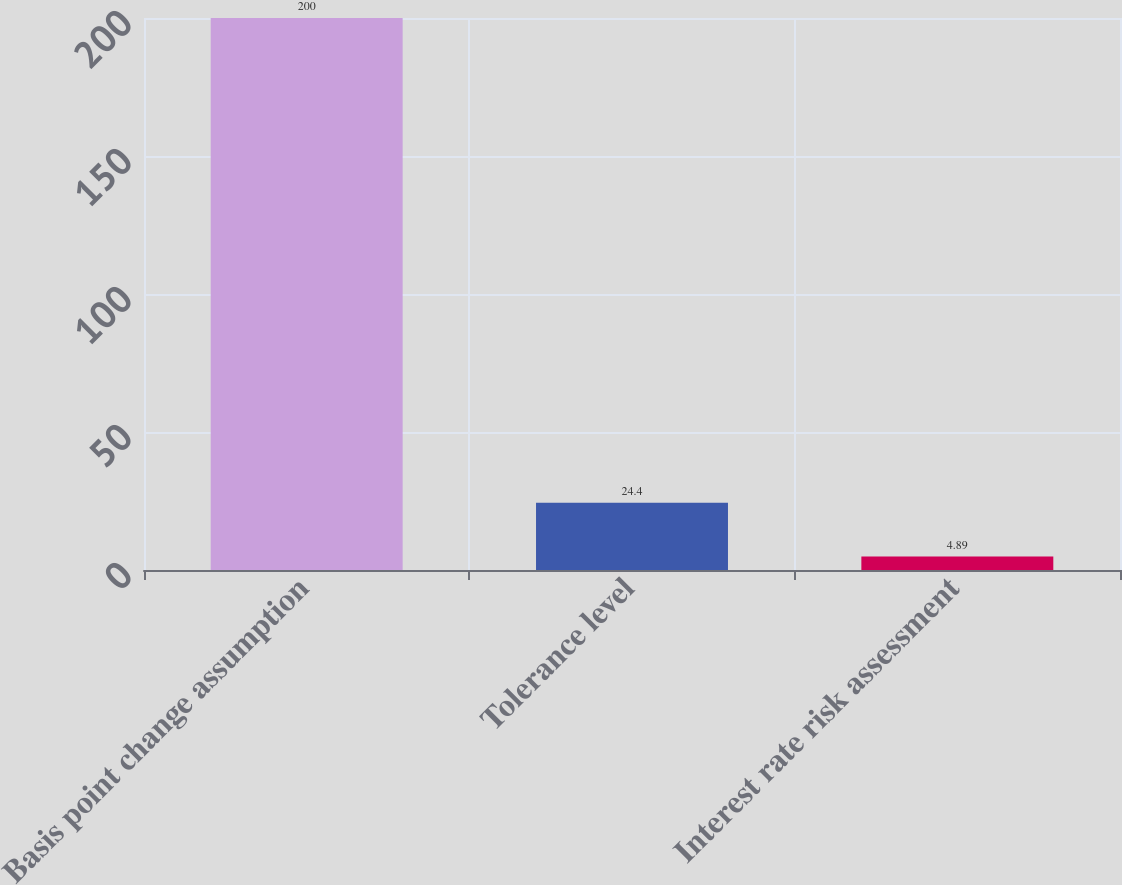Convert chart to OTSL. <chart><loc_0><loc_0><loc_500><loc_500><bar_chart><fcel>Basis point change assumption<fcel>Tolerance level<fcel>Interest rate risk assessment<nl><fcel>200<fcel>24.4<fcel>4.89<nl></chart> 